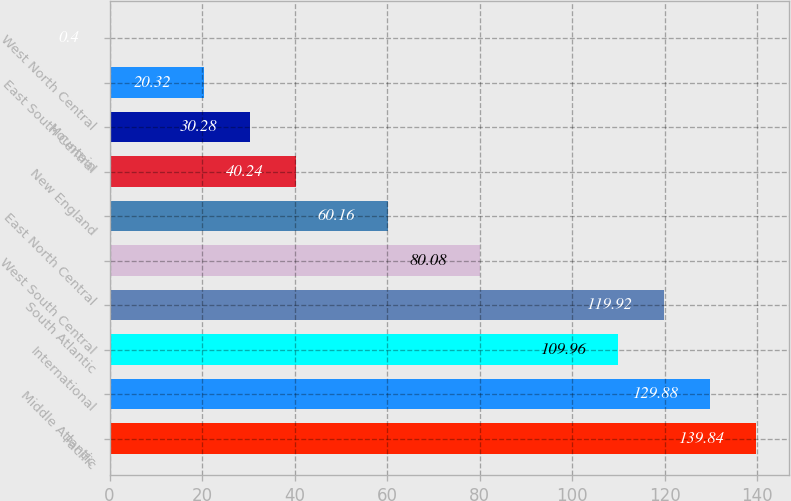<chart> <loc_0><loc_0><loc_500><loc_500><bar_chart><fcel>Pacific<fcel>Middle Atlantic<fcel>International<fcel>South Atlantic<fcel>West South Central<fcel>East North Central<fcel>New England<fcel>Mountain<fcel>East South Central<fcel>West North Central<nl><fcel>139.84<fcel>129.88<fcel>109.96<fcel>119.92<fcel>80.08<fcel>60.16<fcel>40.24<fcel>30.28<fcel>20.32<fcel>0.4<nl></chart> 